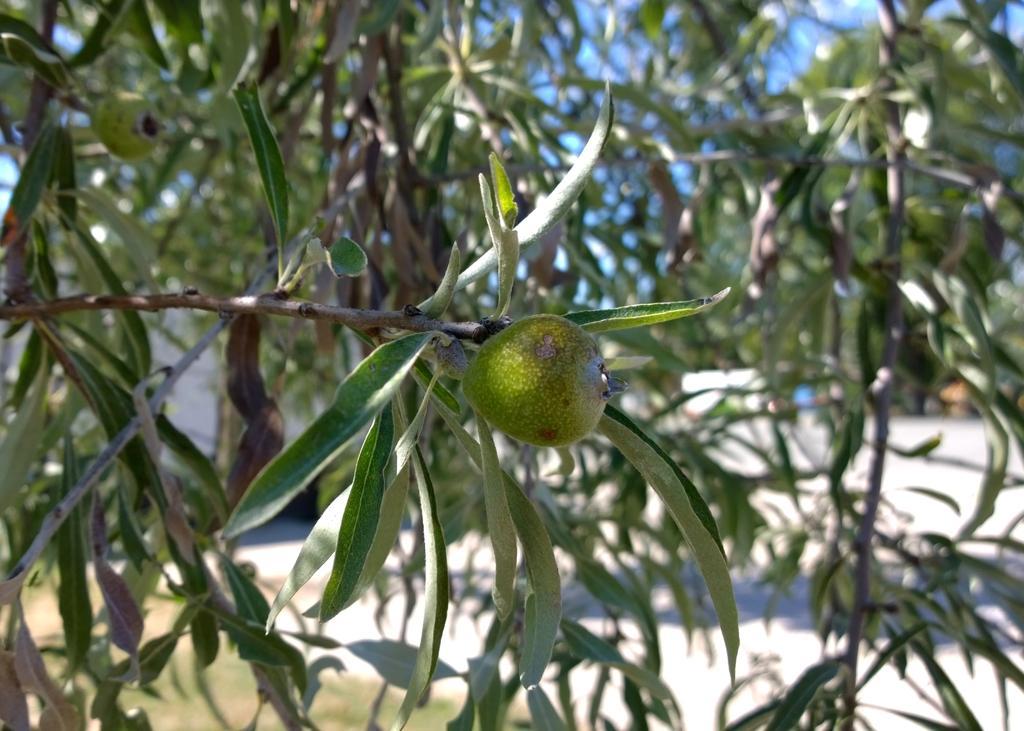How would you summarize this image in a sentence or two? In this picture I can observe green color fruit to the tree in the middle of the picture. In the background there are trees and sky. 